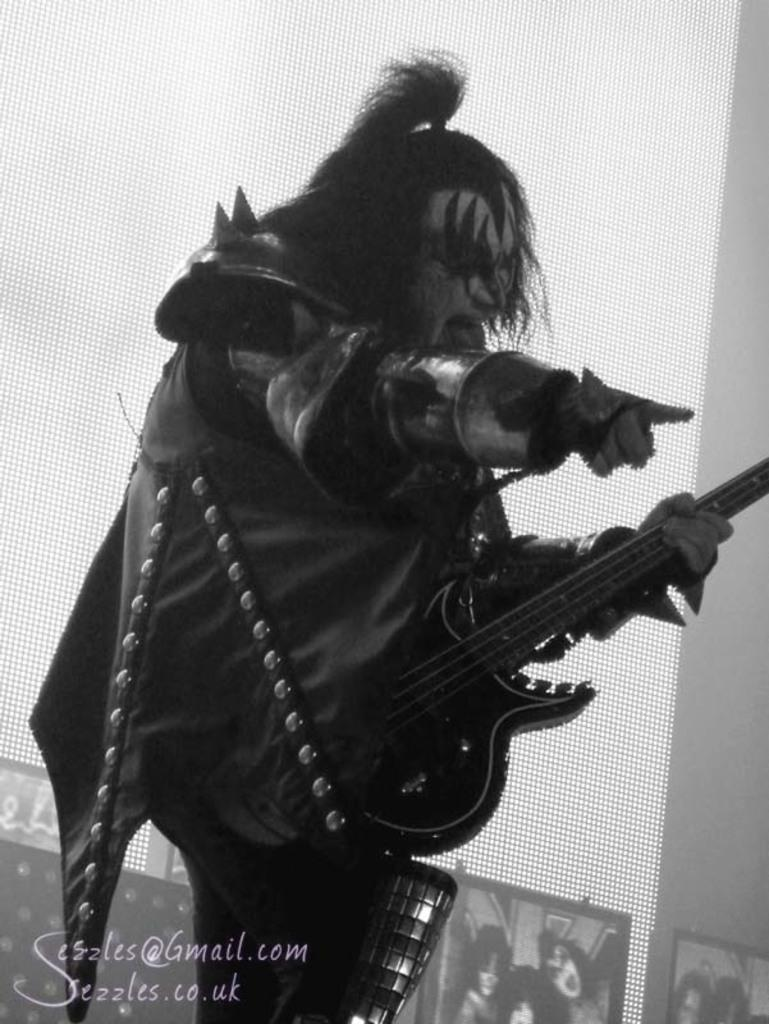What is the main subject of the image? There is a person in the image. What is the person doing in the image? The person is standing and playing a guitar. What can be seen in the background of the image? There is a screen in the background of the image. What type of harmony can be heard in the image? There is no sound or music present in the image, so it is not possible to determine what type of harmony might be heard. 